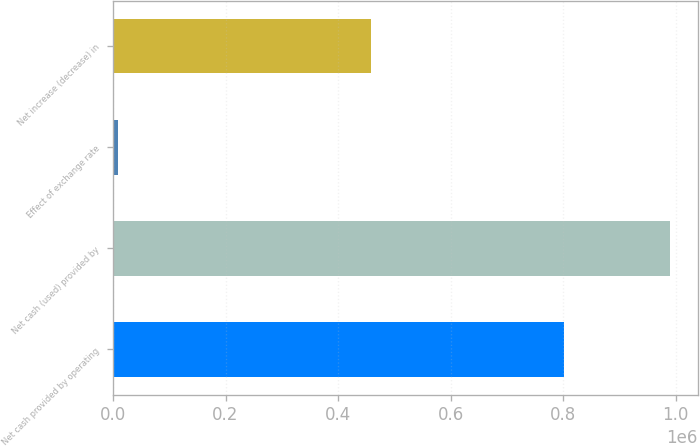<chart> <loc_0><loc_0><loc_500><loc_500><bar_chart><fcel>Net cash provided by operating<fcel>Net cash (used) provided by<fcel>Effect of exchange rate<fcel>Net increase (decrease) in<nl><fcel>801458<fcel>990073<fcel>8886<fcel>458812<nl></chart> 